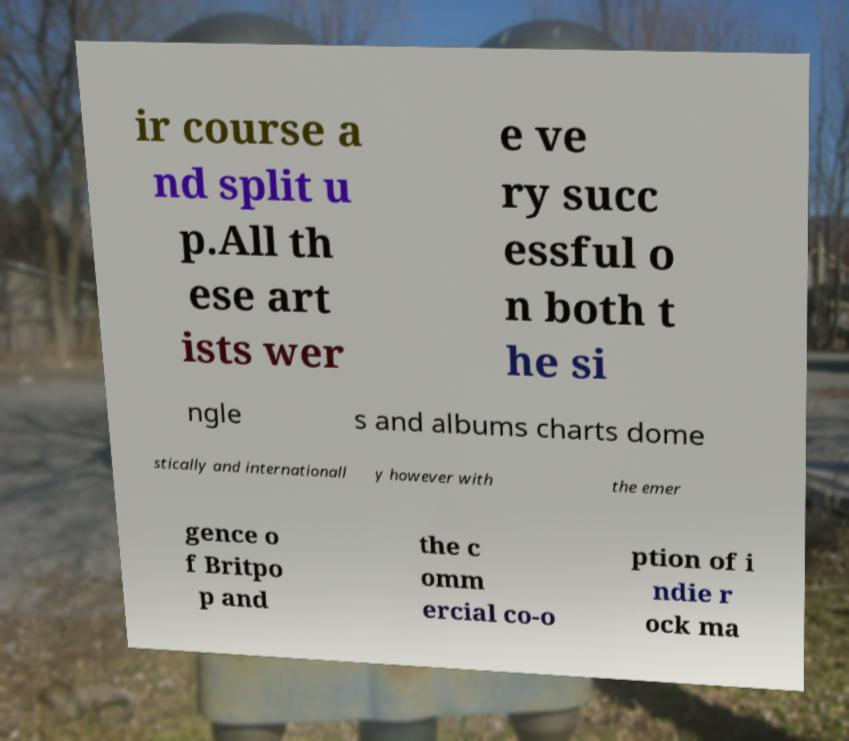Please identify and transcribe the text found in this image. ir course a nd split u p.All th ese art ists wer e ve ry succ essful o n both t he si ngle s and albums charts dome stically and internationall y however with the emer gence o f Britpo p and the c omm ercial co-o ption of i ndie r ock ma 